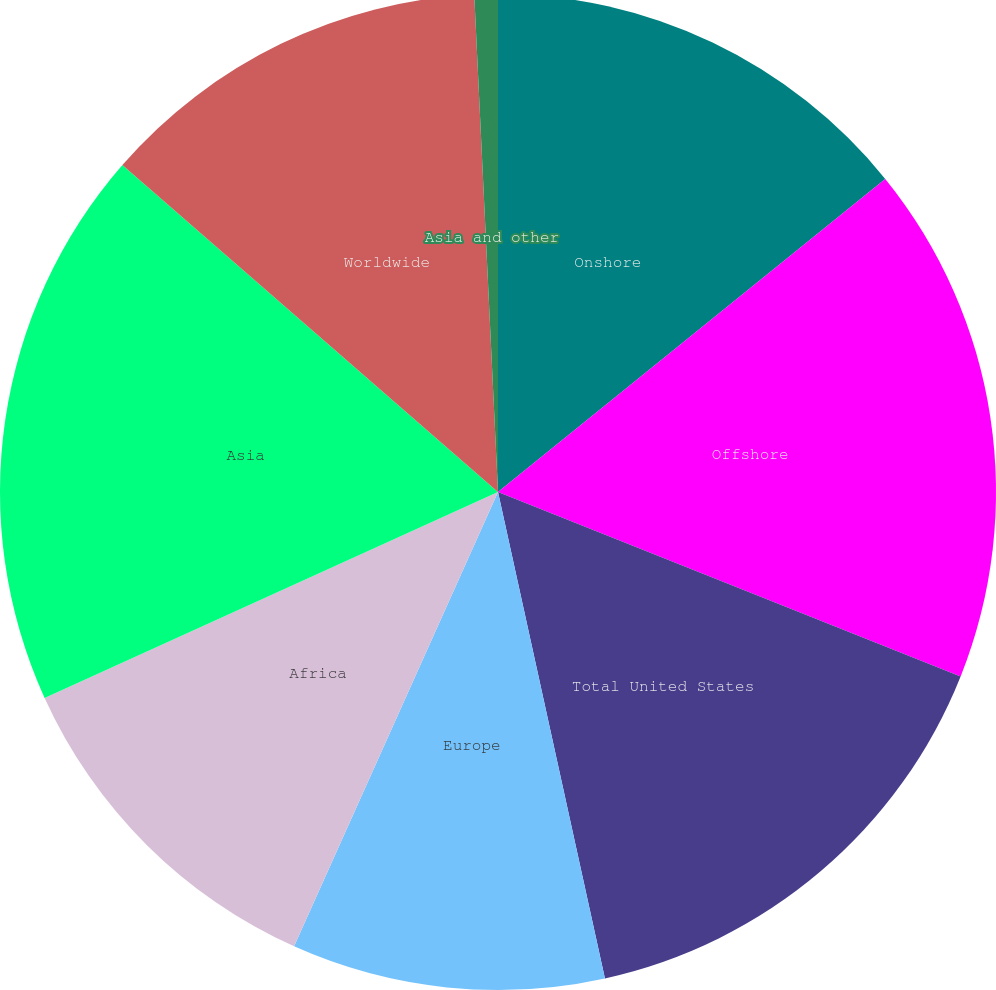<chart> <loc_0><loc_0><loc_500><loc_500><pie_chart><fcel>Onshore<fcel>Offshore<fcel>Total United States<fcel>Europe<fcel>Africa<fcel>Asia<fcel>Worldwide<fcel>Asia and other<nl><fcel>14.18%<fcel>16.86%<fcel>15.52%<fcel>10.16%<fcel>11.5%<fcel>18.19%<fcel>12.84%<fcel>0.76%<nl></chart> 